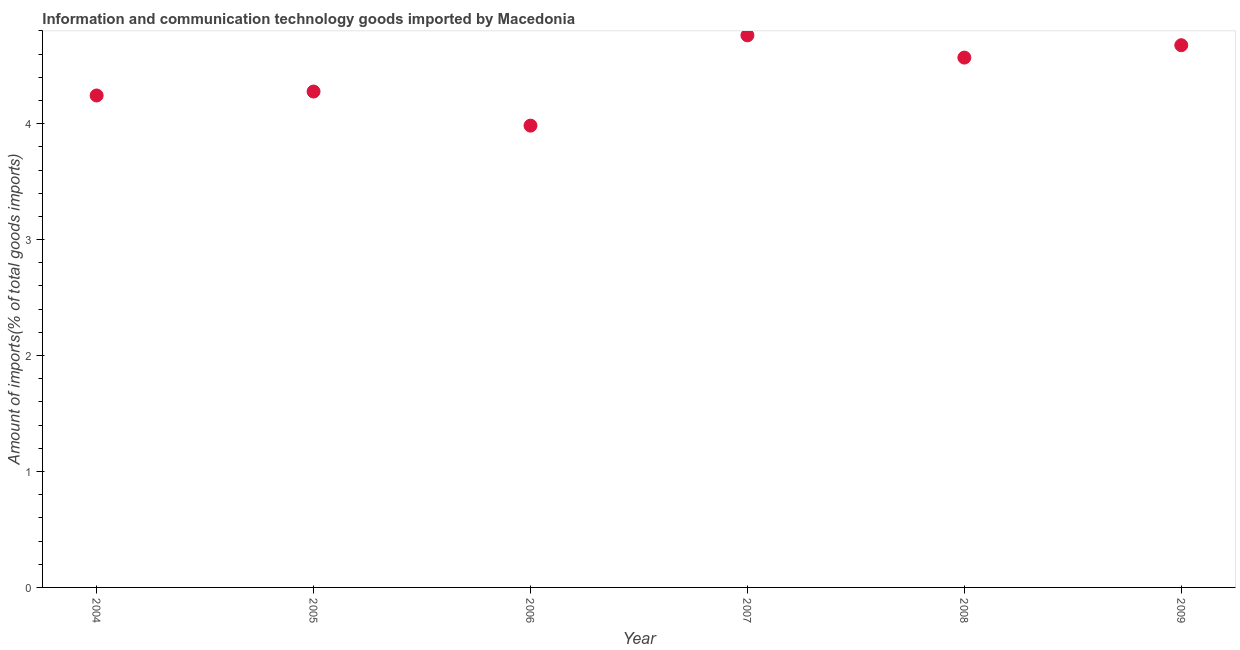What is the amount of ict goods imports in 2004?
Offer a very short reply. 4.24. Across all years, what is the maximum amount of ict goods imports?
Your answer should be very brief. 4.76. Across all years, what is the minimum amount of ict goods imports?
Your answer should be very brief. 3.98. In which year was the amount of ict goods imports minimum?
Your answer should be compact. 2006. What is the sum of the amount of ict goods imports?
Provide a succinct answer. 26.51. What is the difference between the amount of ict goods imports in 2007 and 2008?
Give a very brief answer. 0.19. What is the average amount of ict goods imports per year?
Offer a very short reply. 4.42. What is the median amount of ict goods imports?
Offer a terse response. 4.42. What is the ratio of the amount of ict goods imports in 2005 to that in 2006?
Make the answer very short. 1.07. Is the difference between the amount of ict goods imports in 2005 and 2008 greater than the difference between any two years?
Give a very brief answer. No. What is the difference between the highest and the second highest amount of ict goods imports?
Give a very brief answer. 0.09. Is the sum of the amount of ict goods imports in 2004 and 2007 greater than the maximum amount of ict goods imports across all years?
Keep it short and to the point. Yes. What is the difference between the highest and the lowest amount of ict goods imports?
Ensure brevity in your answer.  0.78. In how many years, is the amount of ict goods imports greater than the average amount of ict goods imports taken over all years?
Your answer should be very brief. 3. How many years are there in the graph?
Offer a terse response. 6. What is the difference between two consecutive major ticks on the Y-axis?
Give a very brief answer. 1. Does the graph contain any zero values?
Make the answer very short. No. What is the title of the graph?
Ensure brevity in your answer.  Information and communication technology goods imported by Macedonia. What is the label or title of the X-axis?
Give a very brief answer. Year. What is the label or title of the Y-axis?
Your answer should be very brief. Amount of imports(% of total goods imports). What is the Amount of imports(% of total goods imports) in 2004?
Ensure brevity in your answer.  4.24. What is the Amount of imports(% of total goods imports) in 2005?
Ensure brevity in your answer.  4.28. What is the Amount of imports(% of total goods imports) in 2006?
Offer a very short reply. 3.98. What is the Amount of imports(% of total goods imports) in 2007?
Offer a terse response. 4.76. What is the Amount of imports(% of total goods imports) in 2008?
Provide a succinct answer. 4.57. What is the Amount of imports(% of total goods imports) in 2009?
Provide a short and direct response. 4.68. What is the difference between the Amount of imports(% of total goods imports) in 2004 and 2005?
Offer a very short reply. -0.03. What is the difference between the Amount of imports(% of total goods imports) in 2004 and 2006?
Your answer should be very brief. 0.26. What is the difference between the Amount of imports(% of total goods imports) in 2004 and 2007?
Provide a short and direct response. -0.52. What is the difference between the Amount of imports(% of total goods imports) in 2004 and 2008?
Offer a very short reply. -0.33. What is the difference between the Amount of imports(% of total goods imports) in 2004 and 2009?
Give a very brief answer. -0.43. What is the difference between the Amount of imports(% of total goods imports) in 2005 and 2006?
Provide a short and direct response. 0.29. What is the difference between the Amount of imports(% of total goods imports) in 2005 and 2007?
Your answer should be compact. -0.48. What is the difference between the Amount of imports(% of total goods imports) in 2005 and 2008?
Give a very brief answer. -0.29. What is the difference between the Amount of imports(% of total goods imports) in 2005 and 2009?
Offer a terse response. -0.4. What is the difference between the Amount of imports(% of total goods imports) in 2006 and 2007?
Provide a short and direct response. -0.78. What is the difference between the Amount of imports(% of total goods imports) in 2006 and 2008?
Make the answer very short. -0.59. What is the difference between the Amount of imports(% of total goods imports) in 2006 and 2009?
Give a very brief answer. -0.69. What is the difference between the Amount of imports(% of total goods imports) in 2007 and 2008?
Your answer should be compact. 0.19. What is the difference between the Amount of imports(% of total goods imports) in 2007 and 2009?
Ensure brevity in your answer.  0.09. What is the difference between the Amount of imports(% of total goods imports) in 2008 and 2009?
Give a very brief answer. -0.11. What is the ratio of the Amount of imports(% of total goods imports) in 2004 to that in 2006?
Offer a terse response. 1.06. What is the ratio of the Amount of imports(% of total goods imports) in 2004 to that in 2007?
Offer a terse response. 0.89. What is the ratio of the Amount of imports(% of total goods imports) in 2004 to that in 2008?
Ensure brevity in your answer.  0.93. What is the ratio of the Amount of imports(% of total goods imports) in 2004 to that in 2009?
Your answer should be very brief. 0.91. What is the ratio of the Amount of imports(% of total goods imports) in 2005 to that in 2006?
Your response must be concise. 1.07. What is the ratio of the Amount of imports(% of total goods imports) in 2005 to that in 2007?
Offer a very short reply. 0.9. What is the ratio of the Amount of imports(% of total goods imports) in 2005 to that in 2008?
Provide a succinct answer. 0.94. What is the ratio of the Amount of imports(% of total goods imports) in 2005 to that in 2009?
Make the answer very short. 0.92. What is the ratio of the Amount of imports(% of total goods imports) in 2006 to that in 2007?
Provide a short and direct response. 0.84. What is the ratio of the Amount of imports(% of total goods imports) in 2006 to that in 2008?
Provide a succinct answer. 0.87. What is the ratio of the Amount of imports(% of total goods imports) in 2006 to that in 2009?
Ensure brevity in your answer.  0.85. What is the ratio of the Amount of imports(% of total goods imports) in 2007 to that in 2008?
Give a very brief answer. 1.04. What is the ratio of the Amount of imports(% of total goods imports) in 2007 to that in 2009?
Make the answer very short. 1.02. What is the ratio of the Amount of imports(% of total goods imports) in 2008 to that in 2009?
Ensure brevity in your answer.  0.98. 